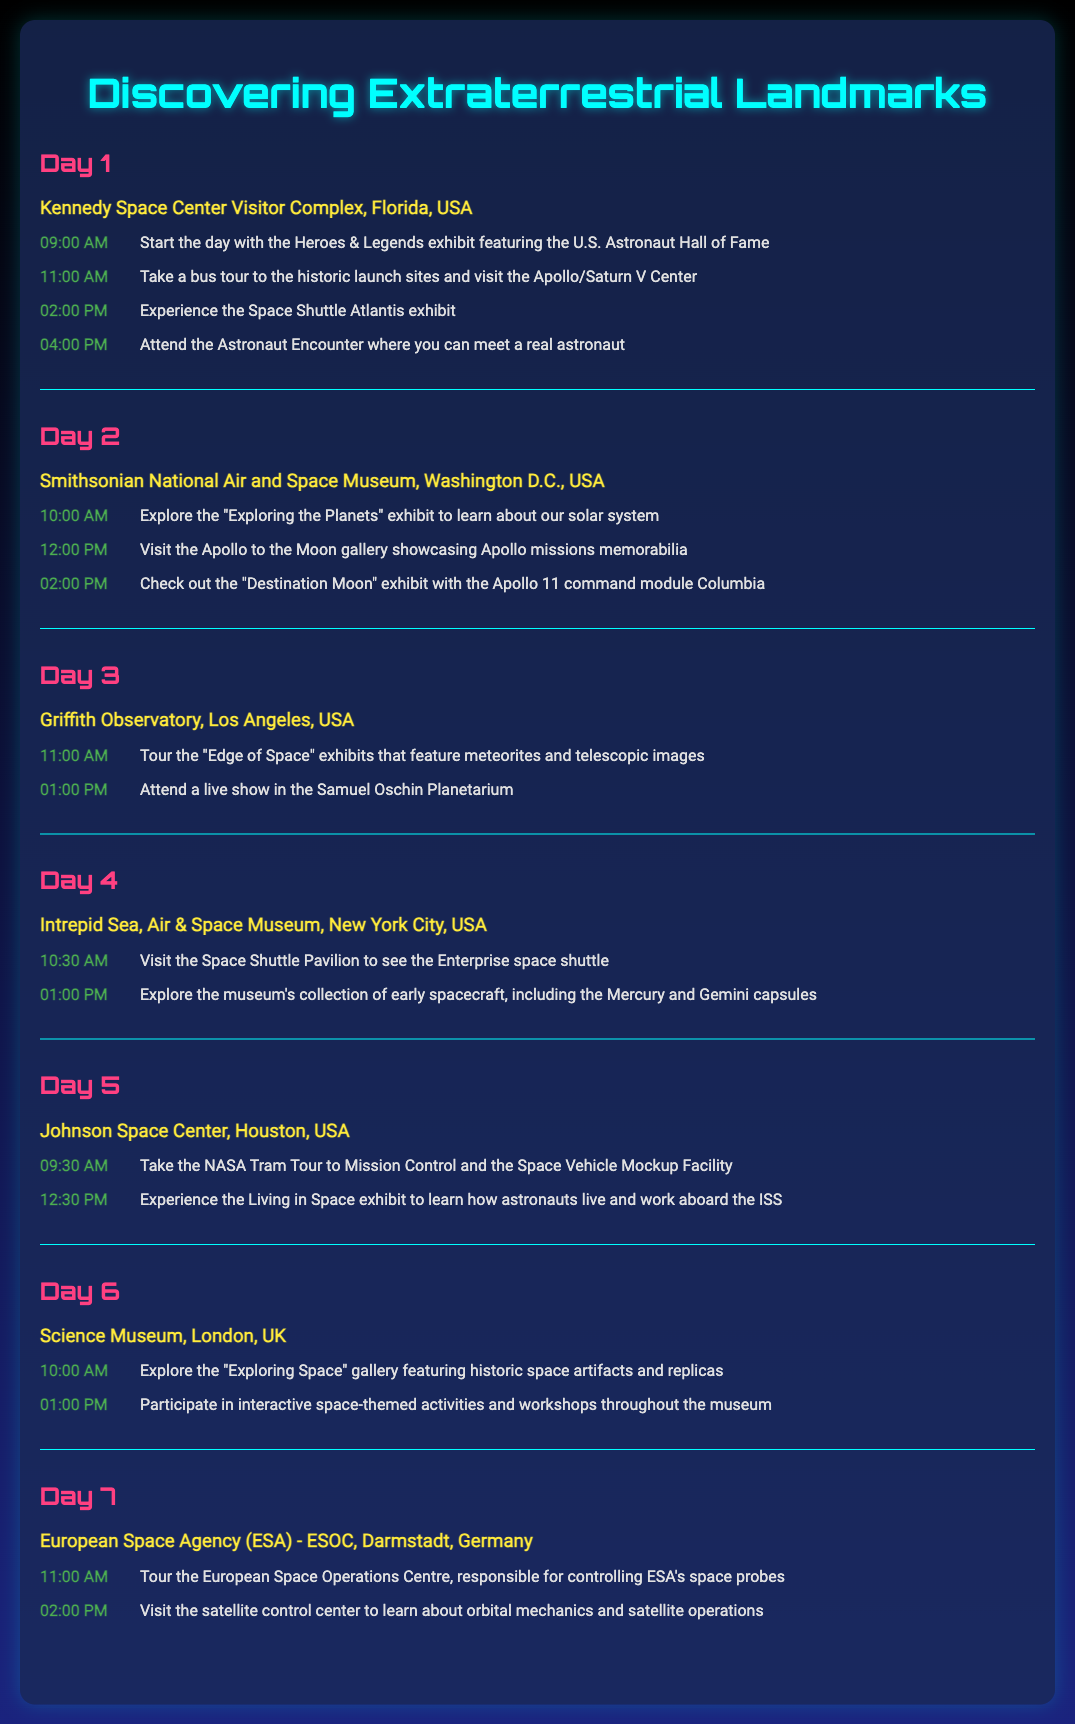What is the first location visited on Day 1? Day 1 starts at the Kennedy Space Center Visitor Complex in Florida, USA.
Answer: Kennedy Space Center Visitor Complex What exhibit can you find at the Smithsonian National Air and Space Museum? The document depicts several exhibits at the Smithsonian National Air and Space Museum, one being "Exploring the Planets."
Answer: Exploring the Planets What time does the NASA Tram Tour start on Day 5? The NASA Tram Tour starts at 09:30 AM according to the activities listed for Day 5.
Answer: 09:30 AM How many days does the itinerary cover? The document outlines activities for a full week, from Day 1 to Day 7.
Answer: 7 Which location features the Space Shuttle Pavilion? The Intrepid Sea, Air & Space Museum is indicated as the location with the Space Shuttle Pavilion.
Answer: Intrepid Sea, Air & Space Museum On which day is the "Living in Space" exhibit scheduled? The "Living in Space" exhibit occurs on Day 5 at the Johnson Space Center.
Answer: Day 5 What is one activity offered at the Griffith Observatory? At Griffith Observatory, attending a live show in the Samuel Oschin Planetarium is one of the activities.
Answer: Live show Which European country is included in the itinerary? The itinerary includes a visit to the Science Museum in London, which is in the UK.
Answer: UK 